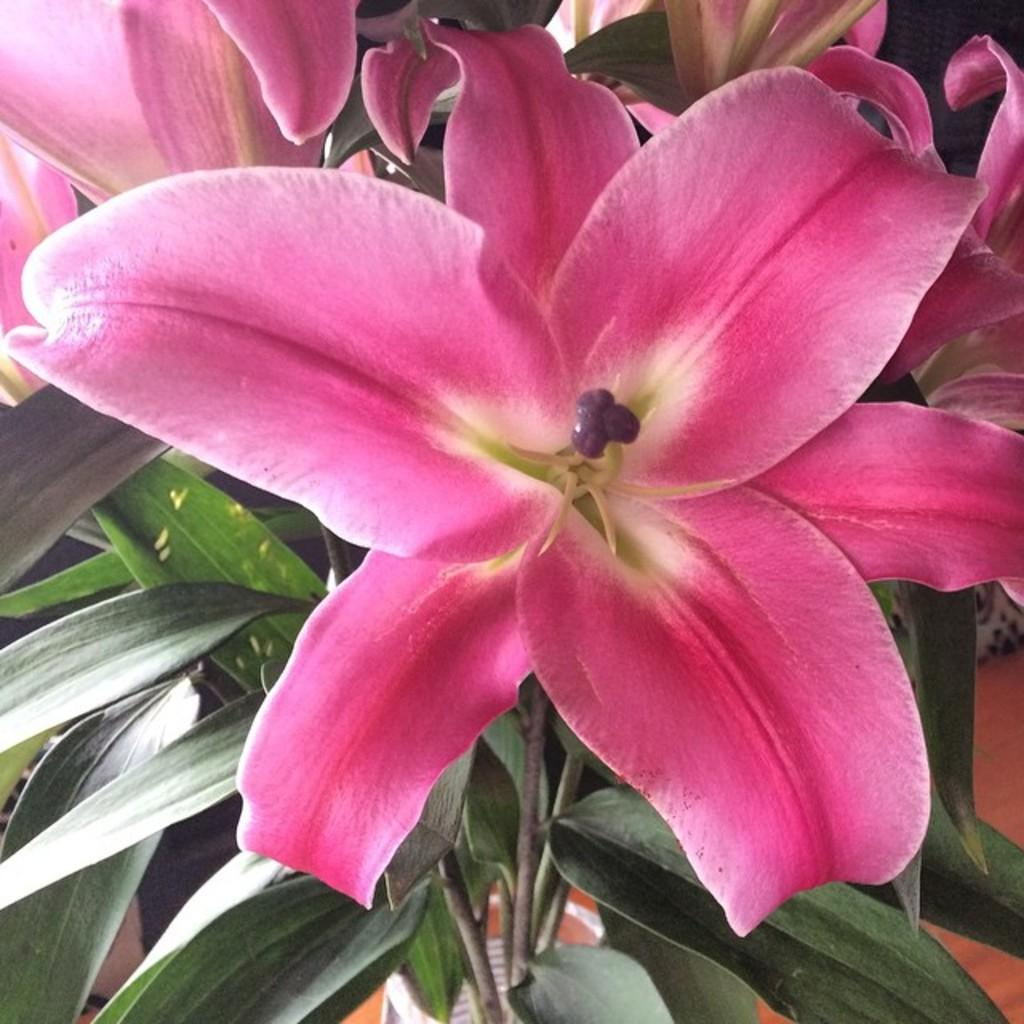What type of plants can be seen in the image? There are flowers in the image. Where are the flowers located in the image? The flowers are in the front of the image. What else can be seen at the bottom of the image? There are leaves at the bottom of the image. What part of the flowers is visible in the image? The petals of the flowers are visible. What type of protest is taking place in the image? There is no protest present in the image; it features flowers and leaves. What type of string is used to tie the flowers together in the image? There is no string present in the image; the flowers are not tied together. 